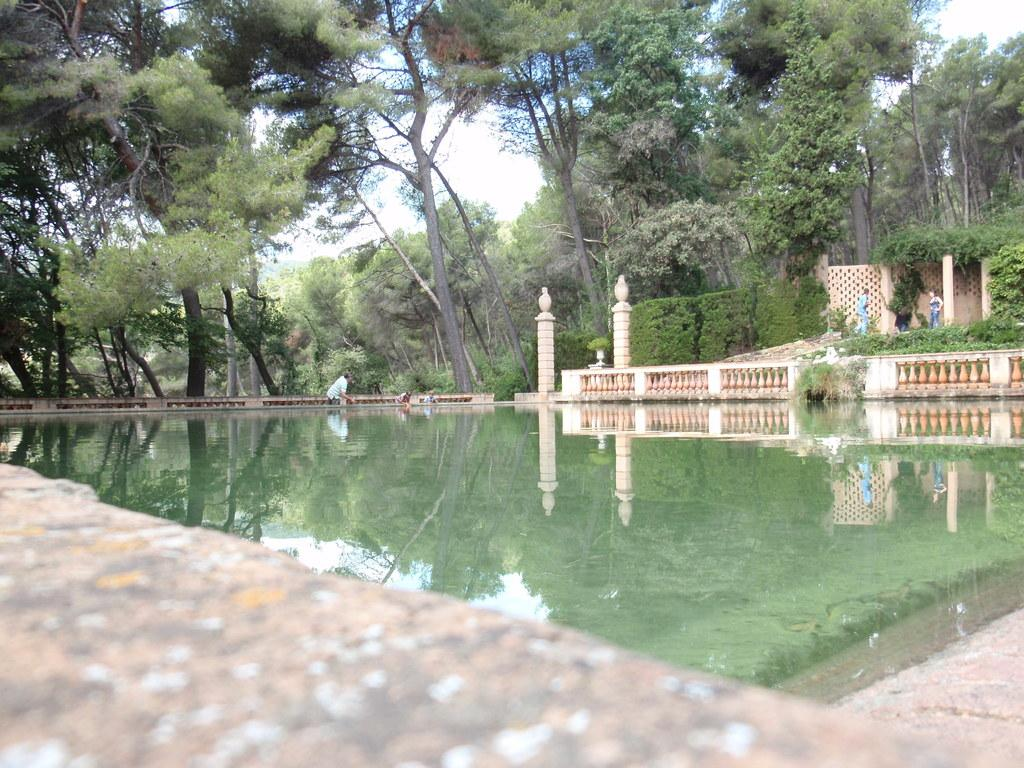What is located at the bottom of the image? There is a lake and a wall at the bottom of the image. What can be seen in the background of the image? There is a building, railings, poles, persons, and trees in the background of the image. What type of nail is being used to hold the property together in the image? There is no nail or property present in the image. What causes the lake to burst in the image? There is no indication of a bursting lake in the image. 